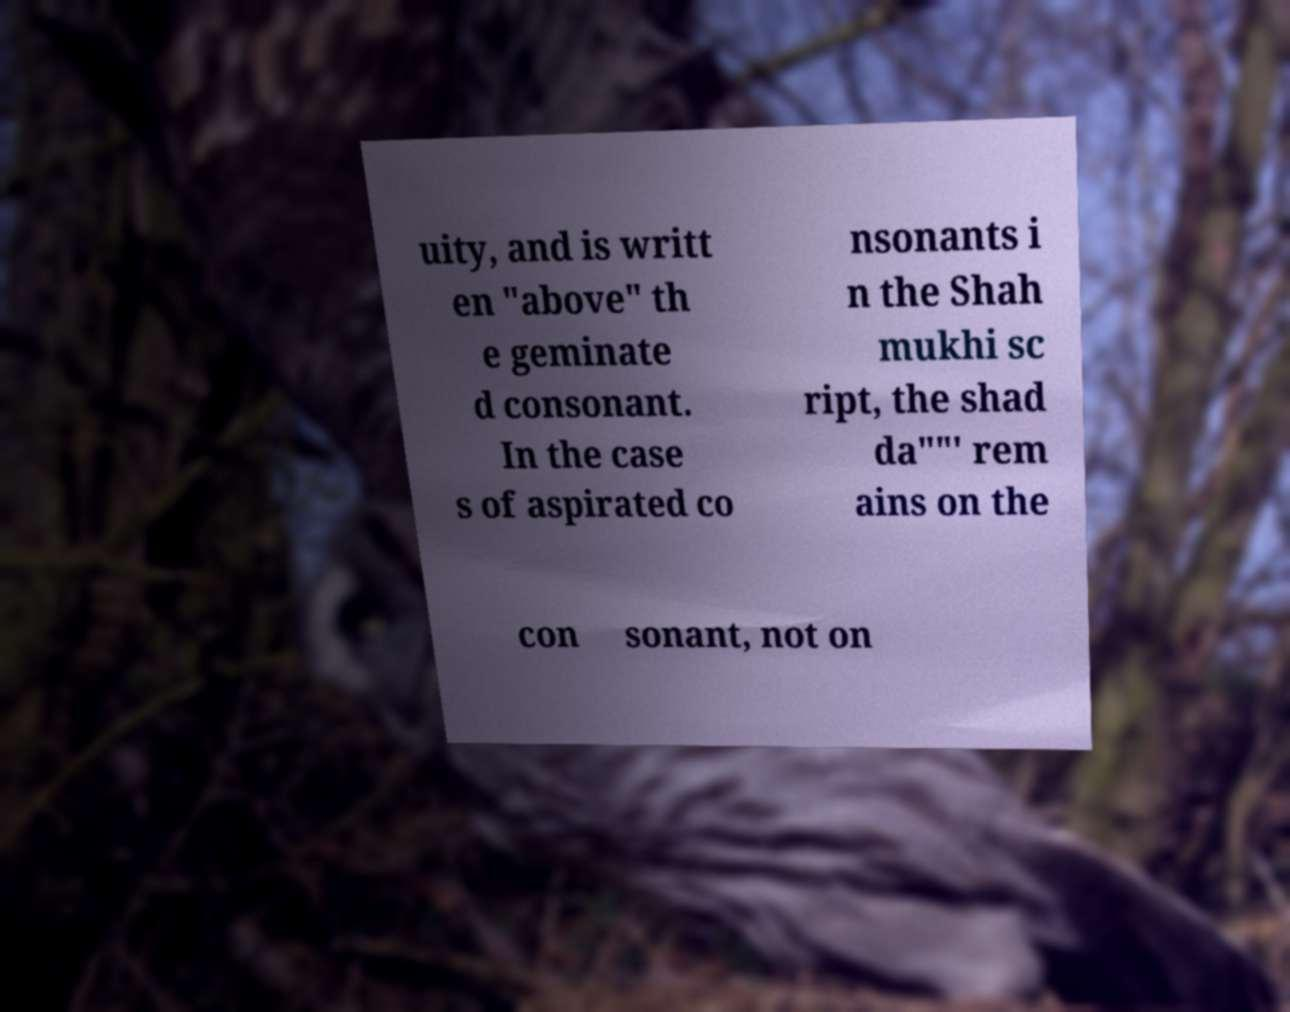Could you assist in decoding the text presented in this image and type it out clearly? uity, and is writt en "above" th e geminate d consonant. In the case s of aspirated co nsonants i n the Shah mukhi sc ript, the shad da""' rem ains on the con sonant, not on 